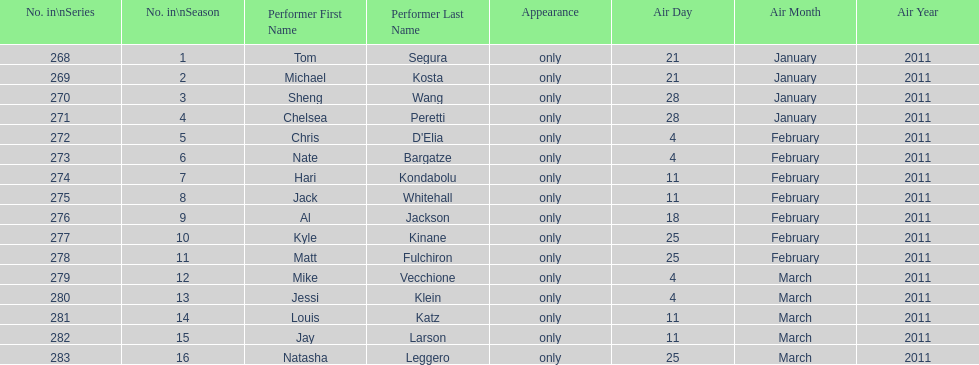How many performers appeared on the air date 21 january 2011? 2. 